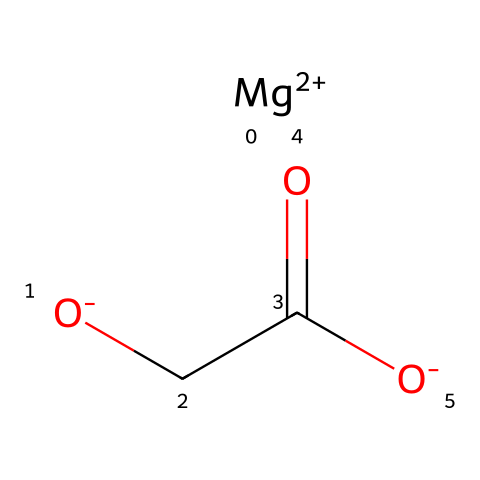What metal is present in this compound? The SMILES representation shows "[Mg+2]", indicating the presence of magnesium as the metal in the compound.
Answer: magnesium How many oxygen atoms are in the structure? The chemical structure includes two "-O" and one "=O" in the carboxylate group, totaling three oxygen atoms in the molecule.
Answer: three What is the charge of the magnesium ion? The notation "[Mg+2]" indicates that the magnesium atom carries a +2 charge.
Answer: +2 What type of functional groups are present in this compound? The compound contains a carboxylate group (indicated by "CC(=O)[O-]") which is characteristic of acidic compounds and gives it hydrophilic properties.
Answer: carboxylate Is this compound likely to be soluble in water? The presence of both a charged magnesium ion and the polar carboxylate functional group suggests that the compound is likely highly soluble in water.
Answer: yes What role does magnesium play in hydration? Magnesium is a crucial electrolyte that helps maintain fluid balance, supports muscle function, and reduces the risk of cramps during physical activities like hockey.
Answer: electrolyte 